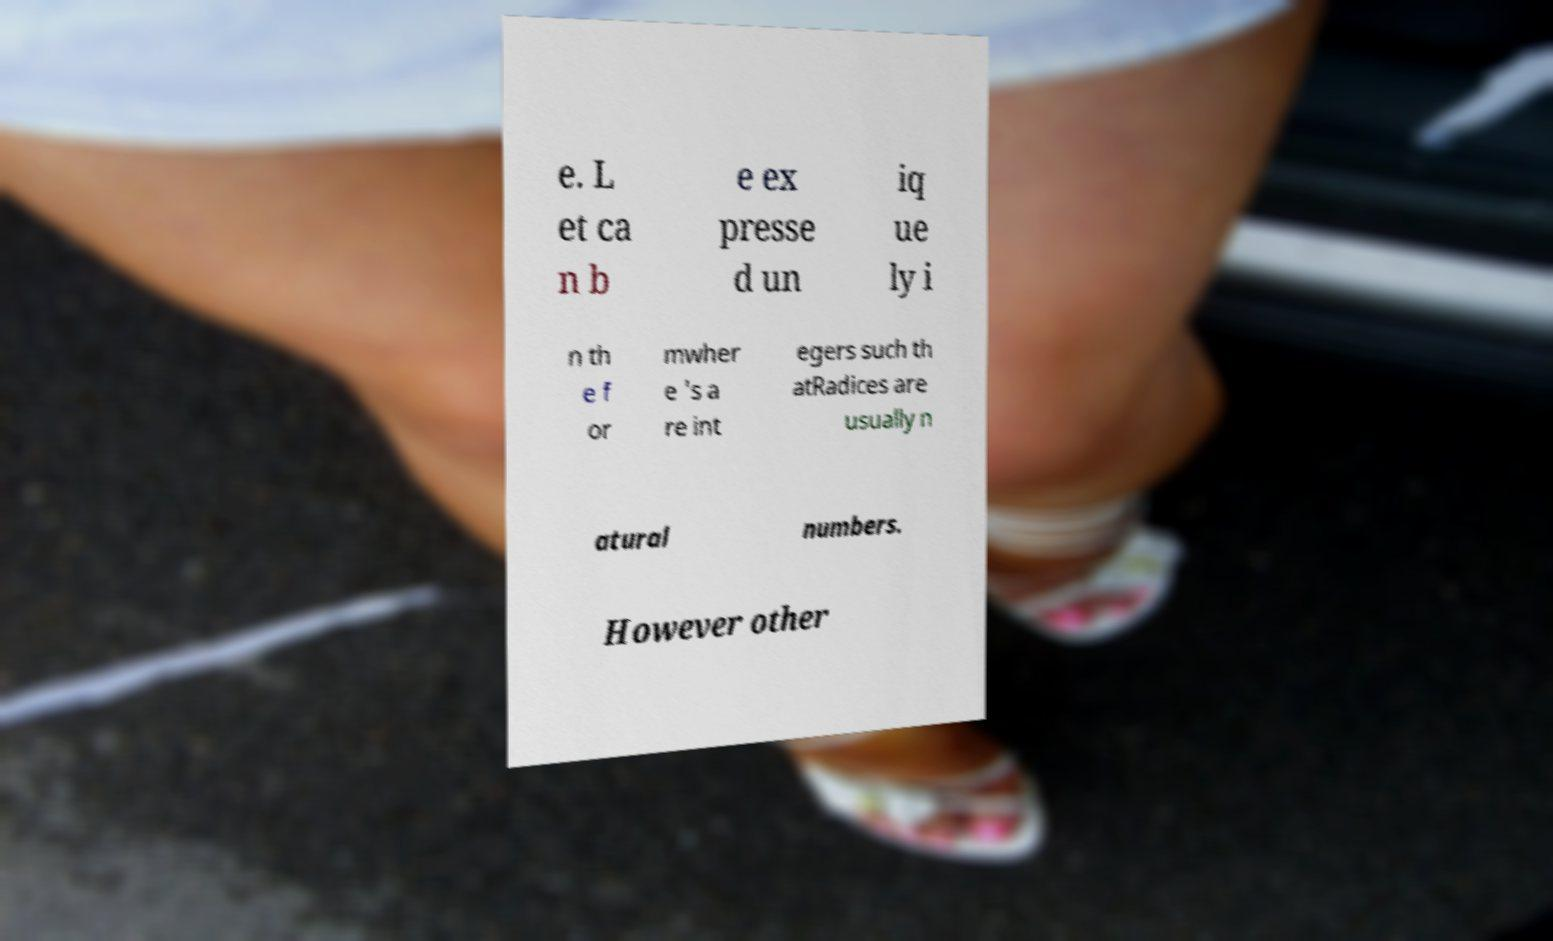Can you accurately transcribe the text from the provided image for me? e. L et ca n b e ex presse d un iq ue ly i n th e f or mwher e 's a re int egers such th atRadices are usually n atural numbers. However other 